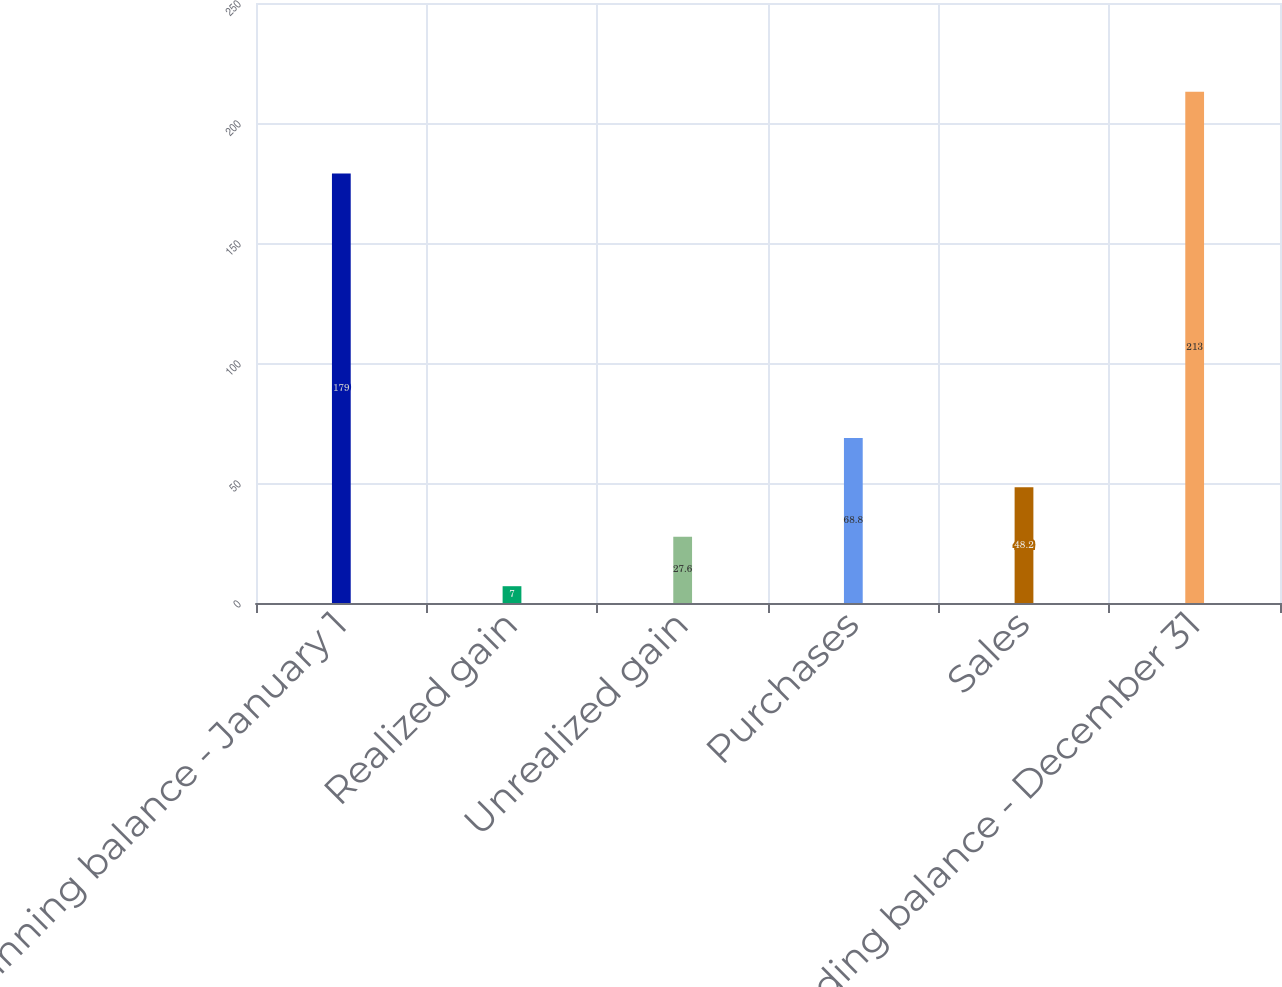<chart> <loc_0><loc_0><loc_500><loc_500><bar_chart><fcel>Beginning balance - January 1<fcel>Realized gain<fcel>Unrealized gain<fcel>Purchases<fcel>Sales<fcel>Ending balance - December 31<nl><fcel>179<fcel>7<fcel>27.6<fcel>68.8<fcel>48.2<fcel>213<nl></chart> 